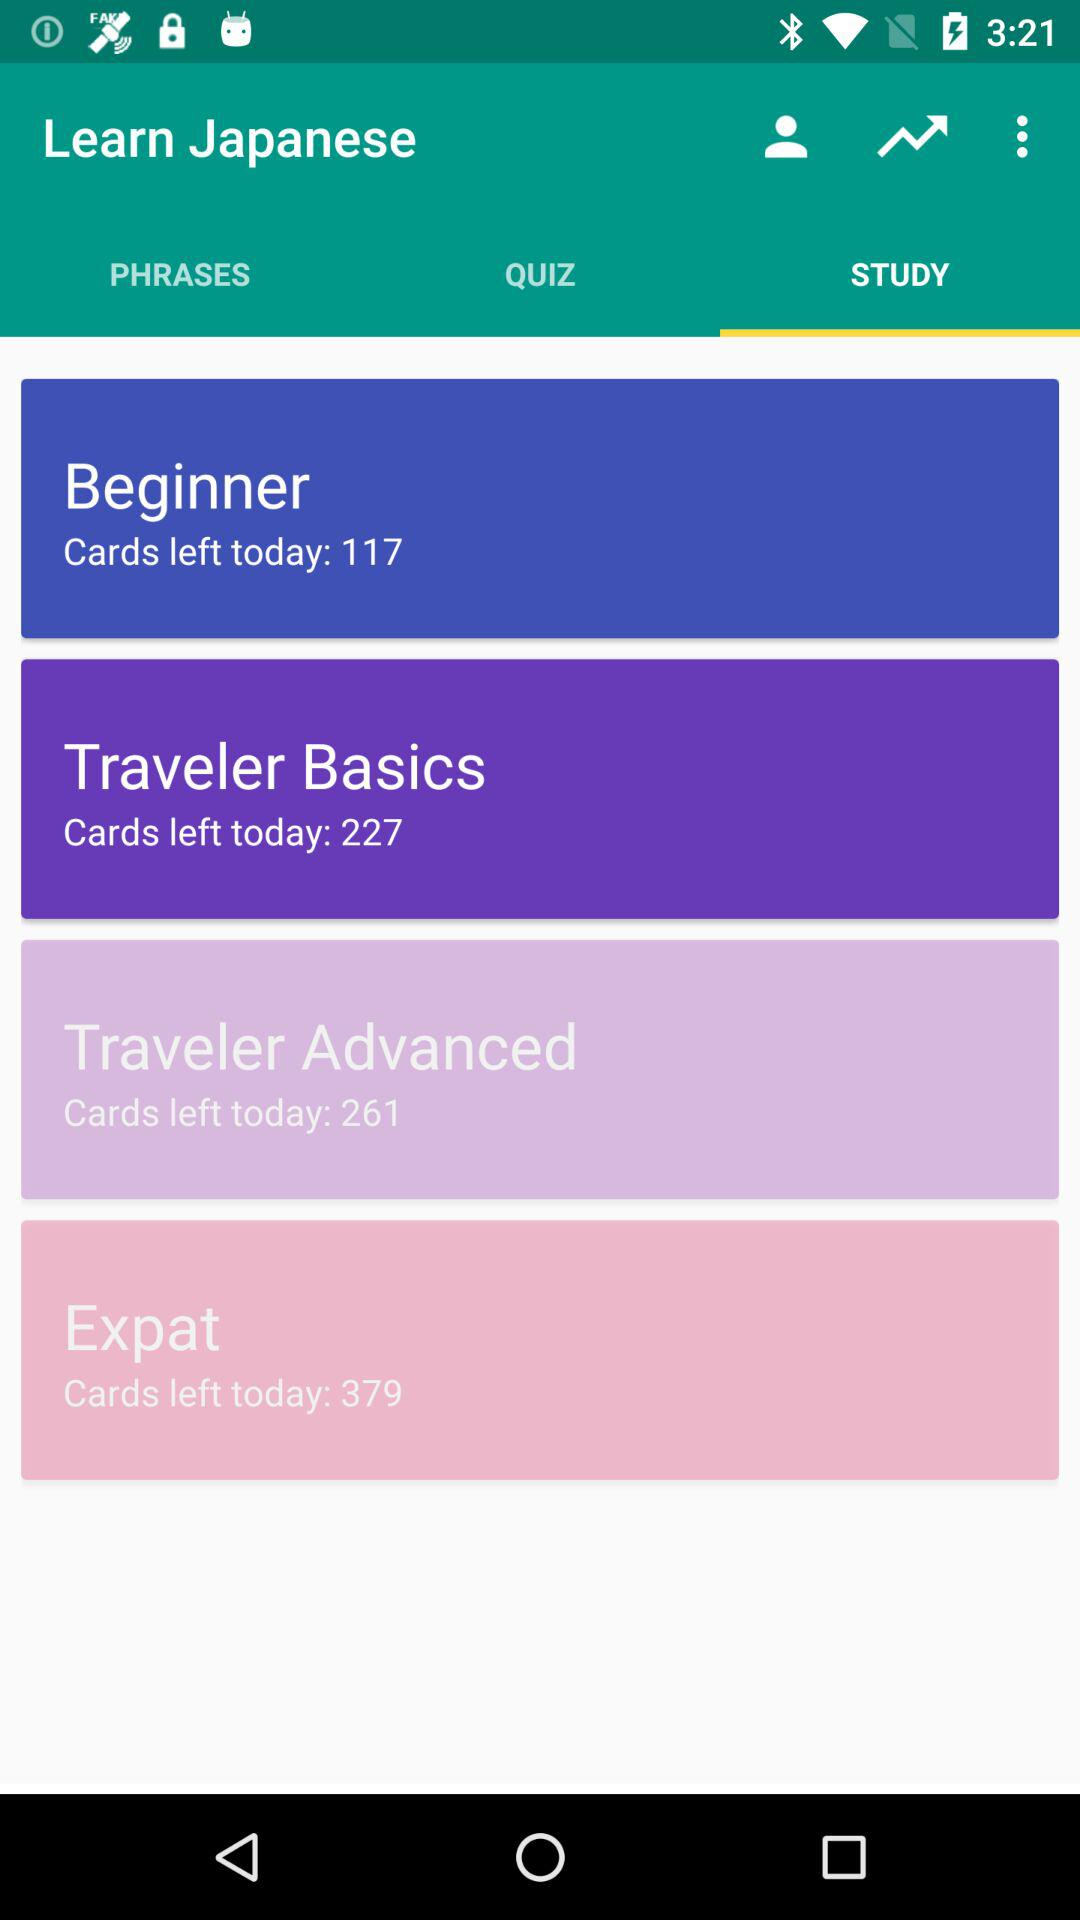How many levels are there in total?
Answer the question using a single word or phrase. 4 